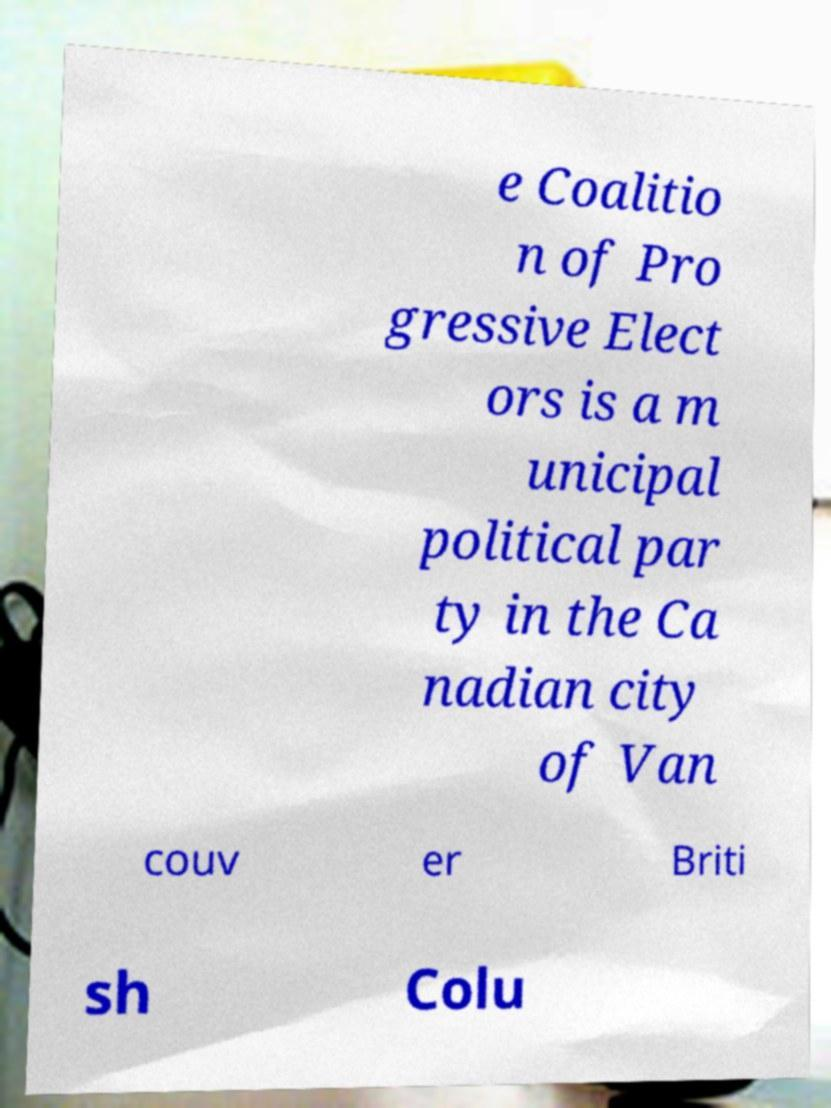I need the written content from this picture converted into text. Can you do that? e Coalitio n of Pro gressive Elect ors is a m unicipal political par ty in the Ca nadian city of Van couv er Briti sh Colu 